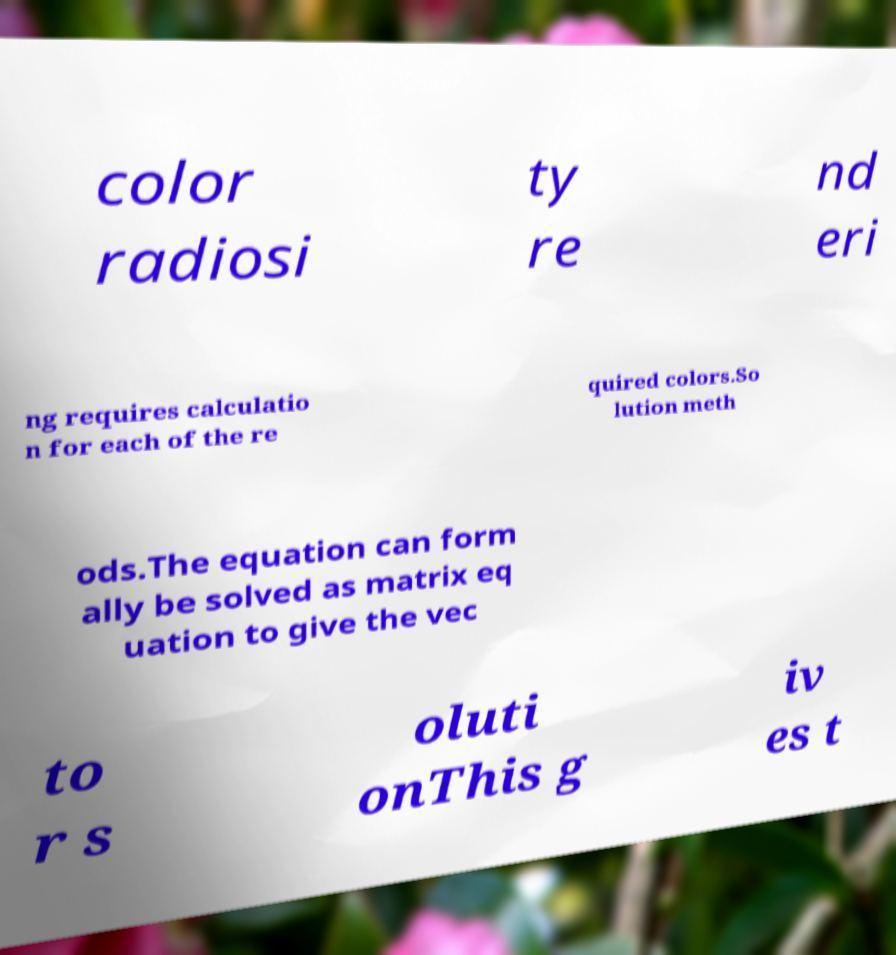Could you extract and type out the text from this image? color radiosi ty re nd eri ng requires calculatio n for each of the re quired colors.So lution meth ods.The equation can form ally be solved as matrix eq uation to give the vec to r s oluti onThis g iv es t 